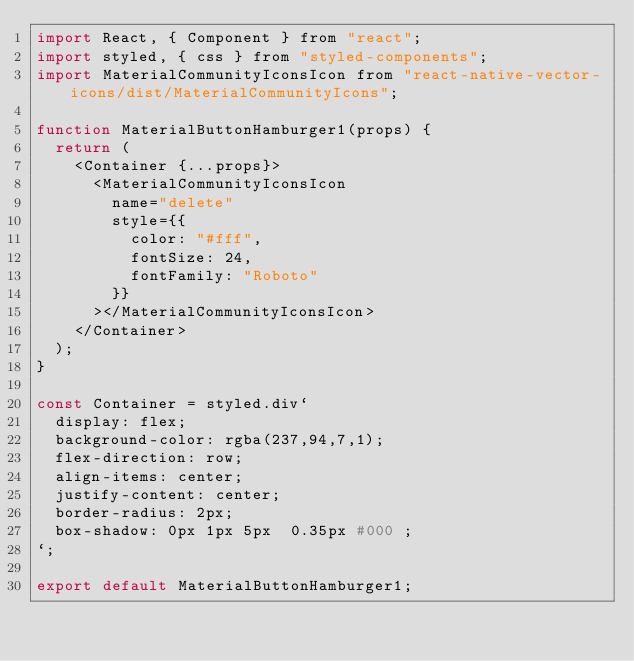Convert code to text. <code><loc_0><loc_0><loc_500><loc_500><_JavaScript_>import React, { Component } from "react";
import styled, { css } from "styled-components";
import MaterialCommunityIconsIcon from "react-native-vector-icons/dist/MaterialCommunityIcons";

function MaterialButtonHamburger1(props) {
  return (
    <Container {...props}>
      <MaterialCommunityIconsIcon
        name="delete"
        style={{
          color: "#fff",
          fontSize: 24,
          fontFamily: "Roboto"
        }}
      ></MaterialCommunityIconsIcon>
    </Container>
  );
}

const Container = styled.div`
  display: flex;
  background-color: rgba(237,94,7,1);
  flex-direction: row;
  align-items: center;
  justify-content: center;
  border-radius: 2px;
  box-shadow: 0px 1px 5px  0.35px #000 ;
`;

export default MaterialButtonHamburger1;
</code> 